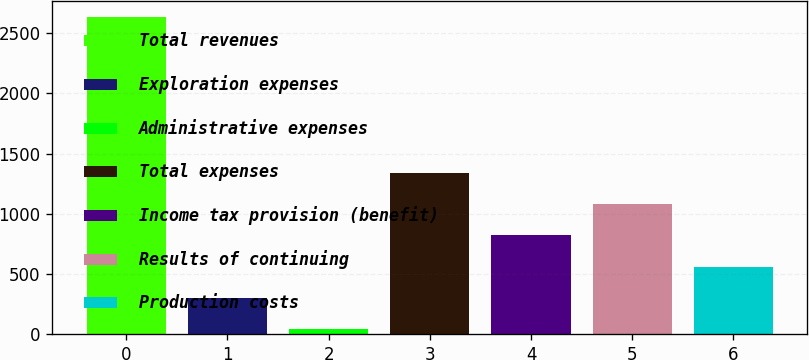Convert chart. <chart><loc_0><loc_0><loc_500><loc_500><bar_chart><fcel>Total revenues<fcel>Exploration expenses<fcel>Administrative expenses<fcel>Total expenses<fcel>Income tax provision (benefit)<fcel>Results of continuing<fcel>Production costs<nl><fcel>2639<fcel>300.8<fcel>41<fcel>1340<fcel>820.4<fcel>1080.2<fcel>560.6<nl></chart> 